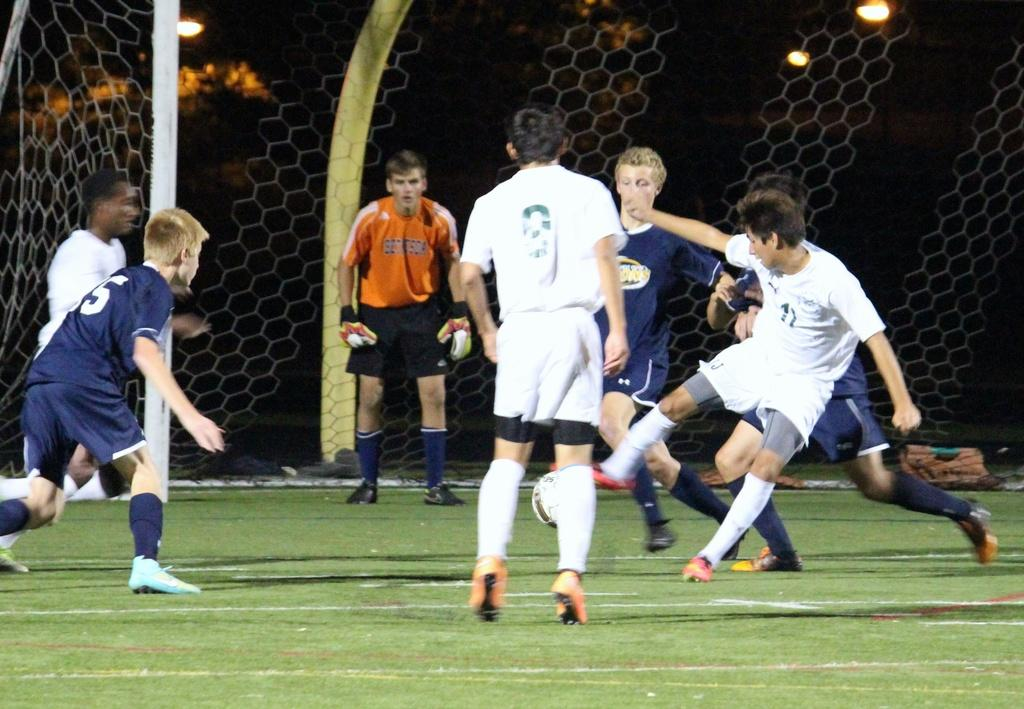How many people are in the image? There is a group of people in the image. What activity are the people engaged in? The people are playing football. What can be seen in the image that provides illumination? There are lights visible in the image. What is used to catch or block the football in the image? There is a net in the image. How does the process of digestion affect the people in the image? There is no information about digestion in the image, as it focuses on a group of people playing football. 